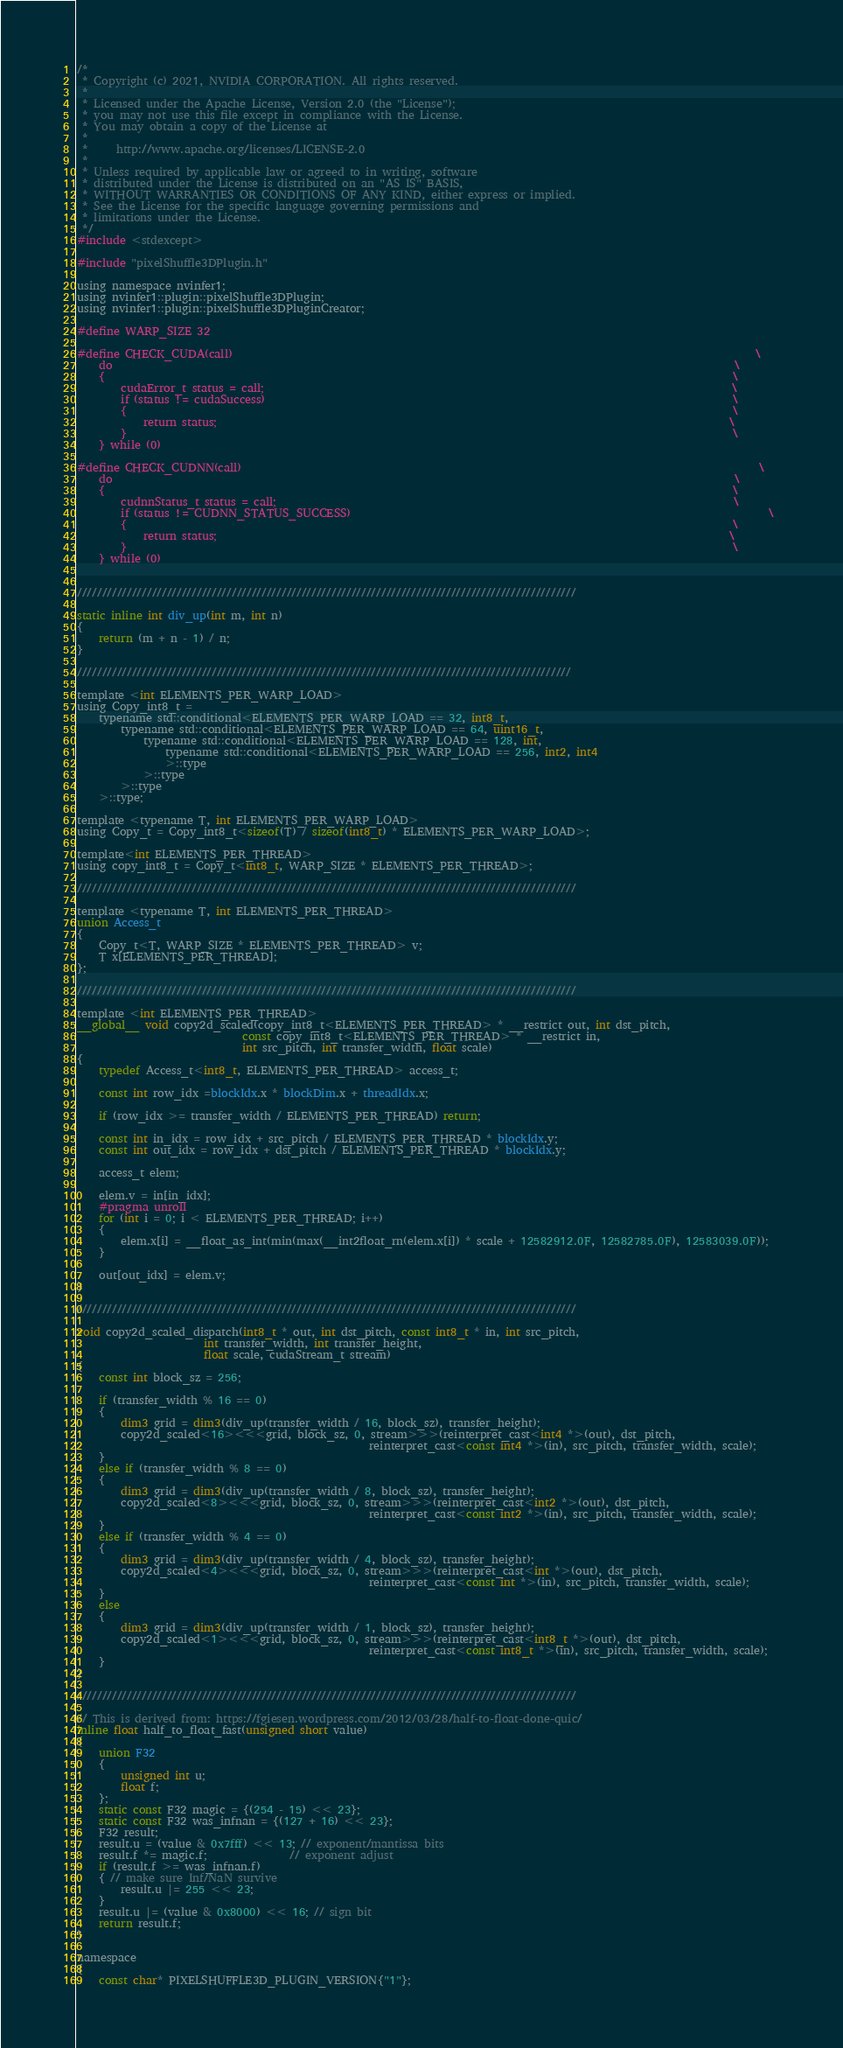Convert code to text. <code><loc_0><loc_0><loc_500><loc_500><_Cuda_>/*
 * Copyright (c) 2021, NVIDIA CORPORATION. All rights reserved.
 *
 * Licensed under the Apache License, Version 2.0 (the "License");
 * you may not use this file except in compliance with the License.
 * You may obtain a copy of the License at
 *
 *     http://www.apache.org/licenses/LICENSE-2.0
 *
 * Unless required by applicable law or agreed to in writing, software
 * distributed under the License is distributed on an "AS IS" BASIS,
 * WITHOUT WARRANTIES OR CONDITIONS OF ANY KIND, either express or implied.
 * See the License for the specific language governing permissions and
 * limitations under the License.
 */
#include <stdexcept>

#include "pixelShuffle3DPlugin.h"

using namespace nvinfer1;
using nvinfer1::plugin::pixelShuffle3DPlugin;
using nvinfer1::plugin::pixelShuffle3DPluginCreator;

#define WARP_SIZE 32

#define CHECK_CUDA(call)                                                                                               \
    do                                                                                                                 \
    {                                                                                                                  \
        cudaError_t status = call;                                                                                     \
        if (status != cudaSuccess)                                                                                     \
        {                                                                                                              \
            return status;                                                                                             \
        }                                                                                                              \
    } while (0)

#define CHECK_CUDNN(call)                                                                                              \
    do                                                                                                                 \
    {                                                                                                                  \
        cudnnStatus_t status = call;                                                                                   \
        if (status != CUDNN_STATUS_SUCCESS)                                                                            \
        {                                                                                                              \
            return status;                                                                                             \
        }                                                                                                              \
    } while (0)


////////////////////////////////////////////////////////////////////////////////////////////////////

static inline int div_up(int m, int n) 
{
    return (m + n - 1) / n;
}

///////////////////////////////////////////////////////////////////////////////////////////////////

template <int ELEMENTS_PER_WARP_LOAD>
using Copy_int8_t =
    typename std::conditional<ELEMENTS_PER_WARP_LOAD == 32, int8_t,
        typename std::conditional<ELEMENTS_PER_WARP_LOAD == 64, uint16_t,
            typename std::conditional<ELEMENTS_PER_WARP_LOAD == 128, int,
                typename std::conditional<ELEMENTS_PER_WARP_LOAD == 256, int2, int4
                >::type
            >::type
        >::type
    >::type;

template <typename T, int ELEMENTS_PER_WARP_LOAD>
using Copy_t = Copy_int8_t<sizeof(T) / sizeof(int8_t) * ELEMENTS_PER_WARP_LOAD>;

template<int ELEMENTS_PER_THREAD>
using copy_int8_t = Copy_t<int8_t, WARP_SIZE * ELEMENTS_PER_THREAD>;

////////////////////////////////////////////////////////////////////////////////////////////////////

template <typename T, int ELEMENTS_PER_THREAD>
union Access_t
{
    Copy_t<T, WARP_SIZE * ELEMENTS_PER_THREAD> v;
    T x[ELEMENTS_PER_THREAD]; 
};

////////////////////////////////////////////////////////////////////////////////////////////////////

template <int ELEMENTS_PER_THREAD>
__global__ void copy2d_scaled(copy_int8_t<ELEMENTS_PER_THREAD> * __restrict out, int dst_pitch,
                              const copy_int8_t<ELEMENTS_PER_THREAD> * __restrict in, 
                              int src_pitch, int transfer_width, float scale) 
{
    typedef Access_t<int8_t, ELEMENTS_PER_THREAD> access_t;

    const int row_idx =blockIdx.x * blockDim.x + threadIdx.x;

    if (row_idx >= transfer_width / ELEMENTS_PER_THREAD) return; 

    const int in_idx = row_idx + src_pitch / ELEMENTS_PER_THREAD * blockIdx.y;
    const int out_idx = row_idx + dst_pitch / ELEMENTS_PER_THREAD * blockIdx.y;

    access_t elem;

    elem.v = in[in_idx];
    #pragma unroll
    for (int i = 0; i < ELEMENTS_PER_THREAD; i++)
    {
        elem.x[i] = __float_as_int(min(max(__int2float_rn(elem.x[i]) * scale + 12582912.0F, 12582785.0F), 12583039.0F));  
    }

    out[out_idx] = elem.v;
}

////////////////////////////////////////////////////////////////////////////////////////////////////

void copy2d_scaled_dispatch(int8_t * out, int dst_pitch, const int8_t * in, int src_pitch, 
                       int transfer_width, int transfer_height,
                       float scale, cudaStream_t stream) 
{
    const int block_sz = 256;

    if (transfer_width % 16 == 0)
    {
        dim3 grid = dim3(div_up(transfer_width / 16, block_sz), transfer_height);
        copy2d_scaled<16><<<grid, block_sz, 0, stream>>>(reinterpret_cast<int4 *>(out), dst_pitch, 
                                                     reinterpret_cast<const int4 *>(in), src_pitch, transfer_width, scale);
    }
    else if (transfer_width % 8 == 0)
    {
        dim3 grid = dim3(div_up(transfer_width / 8, block_sz), transfer_height);
        copy2d_scaled<8><<<grid, block_sz, 0, stream>>>(reinterpret_cast<int2 *>(out), dst_pitch, 
                                                     reinterpret_cast<const int2 *>(in), src_pitch, transfer_width, scale);
    }
    else if (transfer_width % 4 == 0)
    {
        dim3 grid = dim3(div_up(transfer_width / 4, block_sz), transfer_height);
        copy2d_scaled<4><<<grid, block_sz, 0, stream>>>(reinterpret_cast<int *>(out), dst_pitch, 
                                                     reinterpret_cast<const int *>(in), src_pitch, transfer_width, scale);
    }
    else
    {
        dim3 grid = dim3(div_up(transfer_width / 1, block_sz), transfer_height);
        copy2d_scaled<1><<<grid, block_sz, 0, stream>>>(reinterpret_cast<int8_t *>(out), dst_pitch, 
                                                     reinterpret_cast<const int8_t *>(in), src_pitch, transfer_width, scale);
    }
}

////////////////////////////////////////////////////////////////////////////////////////////////////

// This is derived from: https://fgiesen.wordpress.com/2012/03/28/half-to-float-done-quic/
inline float half_to_float_fast(unsigned short value)
{
    union F32
    {
        unsigned int u;
        float f;
    };
    static const F32 magic = {(254 - 15) << 23};
    static const F32 was_infnan = {(127 + 16) << 23};
    F32 result;
    result.u = (value & 0x7fff) << 13; // exponent/mantissa bits
    result.f *= magic.f;               // exponent adjust
    if (result.f >= was_infnan.f)
    { // make sure Inf/NaN survive
        result.u |= 255 << 23;
    }
    result.u |= (value & 0x8000) << 16; // sign bit
    return result.f;
}

namespace 
{
    const char* PIXELSHUFFLE3D_PLUGIN_VERSION{"1"};</code> 